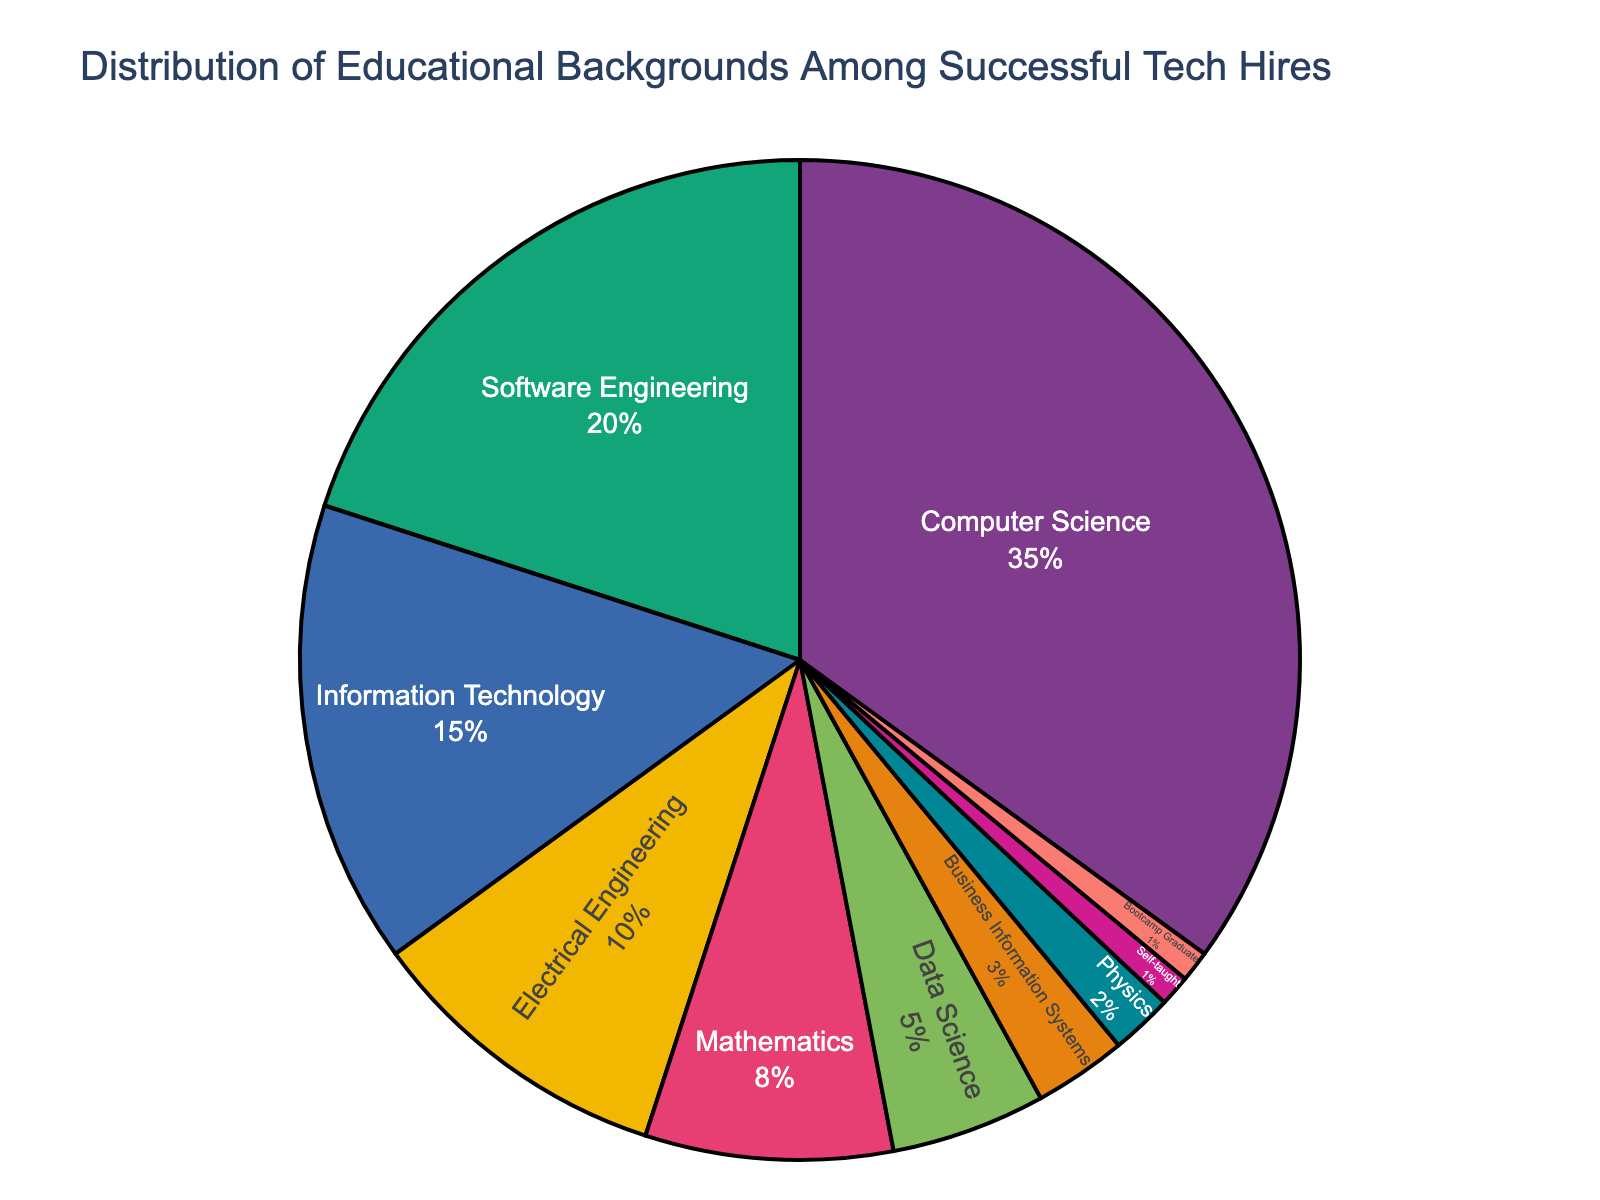what is the most common educational background among successful tech hires? To identify the most common educational background, look for the largest section of the pie chart. The largest portion indicates the group with the highest percentage.
Answer: Computer Science what percentage of successful tech hires have a background in Mathematics or Data Science? Check the pie chart segments representing Mathematics and Data Science. Summing their percentages, we have Mathematics (8%) + Data Science (5%). Thus, 8% + 5% = 13%.
Answer: 13% How does the percentage of successful tech hires with a background in Electrical Engineering compare to those in Information Technology? Compare the two segments on the pie chart. Electrical Engineering represents 10%, while Information Technology represents 15%. Therefore, Information Technology is more prevalent.
Answer: Information Technology is more prevalent What is the least common educational background among successful tech hires? Identify the smallest segments in the pie chart. Both Self-taught and Bootcamp Graduate represent 1% each, making them the least common backgrounds.
Answer: Self-taught and Bootcamp Graduate How many educational backgrounds form 65% of the pie chart? Observe the pie chart and sum the percentages starting from the largest segment until reaching or surpassing 65%. Computer Science (35%) + Software Engineering (20%) + Information Technology (15%) = 70%. 35% + 20% + 15% = 70%, so 3 backgrounds are needed to exceed 65%.
Answer: 3 backgrounds 